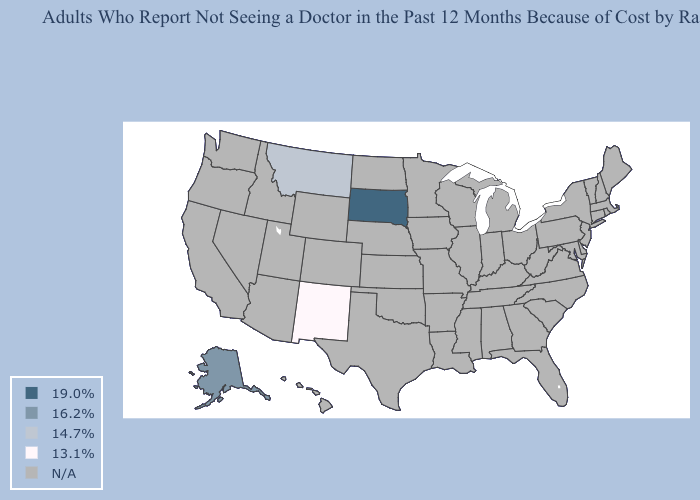What is the value of California?
Concise answer only. N/A. Which states have the highest value in the USA?
Keep it brief. South Dakota. What is the lowest value in the USA?
Keep it brief. 13.1%. Does New Mexico have the highest value in the West?
Keep it brief. No. What is the value of Georgia?
Write a very short answer. N/A. Name the states that have a value in the range 14.7%?
Keep it brief. Montana. What is the value of West Virginia?
Be succinct. N/A. What is the value of Vermont?
Concise answer only. N/A. 